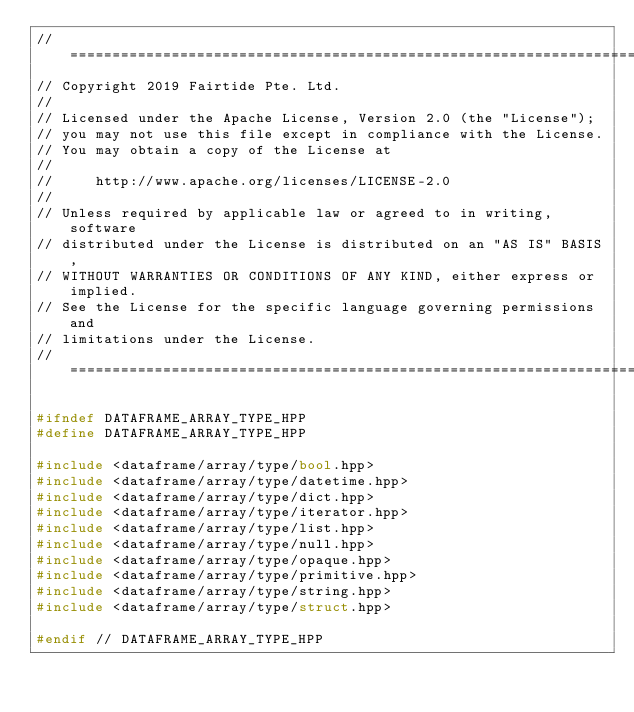Convert code to text. <code><loc_0><loc_0><loc_500><loc_500><_C++_>// ============================================================================
// Copyright 2019 Fairtide Pte. Ltd.
//
// Licensed under the Apache License, Version 2.0 (the "License");
// you may not use this file except in compliance with the License.
// You may obtain a copy of the License at
//
//     http://www.apache.org/licenses/LICENSE-2.0
//
// Unless required by applicable law or agreed to in writing, software
// distributed under the License is distributed on an "AS IS" BASIS,
// WITHOUT WARRANTIES OR CONDITIONS OF ANY KIND, either express or implied.
// See the License for the specific language governing permissions and
// limitations under the License.
// ============================================================================

#ifndef DATAFRAME_ARRAY_TYPE_HPP
#define DATAFRAME_ARRAY_TYPE_HPP

#include <dataframe/array/type/bool.hpp>
#include <dataframe/array/type/datetime.hpp>
#include <dataframe/array/type/dict.hpp>
#include <dataframe/array/type/iterator.hpp>
#include <dataframe/array/type/list.hpp>
#include <dataframe/array/type/null.hpp>
#include <dataframe/array/type/opaque.hpp>
#include <dataframe/array/type/primitive.hpp>
#include <dataframe/array/type/string.hpp>
#include <dataframe/array/type/struct.hpp>

#endif // DATAFRAME_ARRAY_TYPE_HPP
</code> 